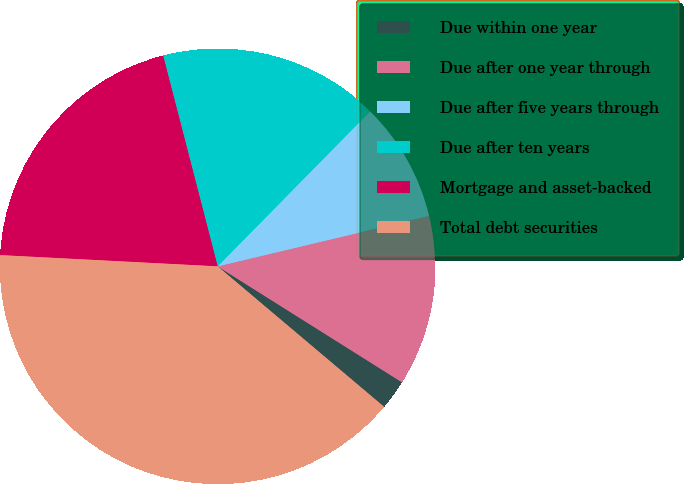Convert chart. <chart><loc_0><loc_0><loc_500><loc_500><pie_chart><fcel>Due within one year<fcel>Due after one year through<fcel>Due after five years through<fcel>Due after ten years<fcel>Mortgage and asset-backed<fcel>Total debt securities<nl><fcel>2.22%<fcel>12.66%<fcel>8.91%<fcel>16.4%<fcel>20.15%<fcel>39.67%<nl></chart> 